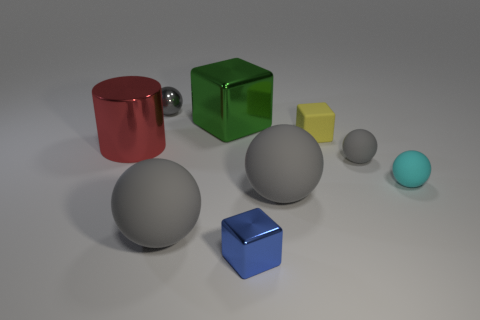Are there any large rubber things of the same color as the tiny metallic sphere?
Provide a short and direct response. Yes. Is the color of the big matte ball that is left of the large green metallic thing the same as the tiny shiny sphere?
Your response must be concise. Yes. What color is the cylinder that is the same size as the green object?
Keep it short and to the point. Red. Do the small matte object behind the cylinder and the tiny blue metal thing have the same shape?
Offer a very short reply. Yes. What color is the large object in front of the large gray matte sphere that is behind the big ball left of the small blue metal thing?
Your answer should be very brief. Gray. Are any large spheres visible?
Offer a very short reply. Yes. How many other objects are there of the same size as the yellow thing?
Provide a short and direct response. 4. There is a tiny shiny ball; is it the same color as the large rubber sphere that is to the left of the small blue cube?
Ensure brevity in your answer.  Yes. What number of things are small brown cubes or small metal things?
Offer a terse response. 2. Is there anything else of the same color as the big block?
Offer a terse response. No. 